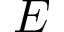<formula> <loc_0><loc_0><loc_500><loc_500>E</formula> 